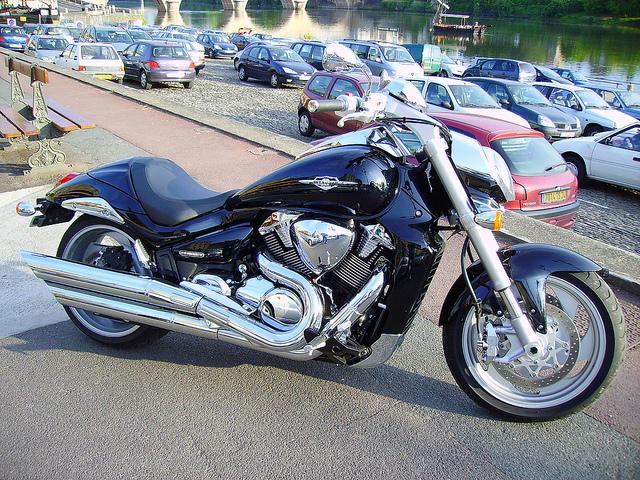What color is the car closest to the motorcycle?
Give a very brief answer. Red. What is the main focus of the picture?
Give a very brief answer. Motorcycle. Are the cars parked?
Give a very brief answer. Yes. 